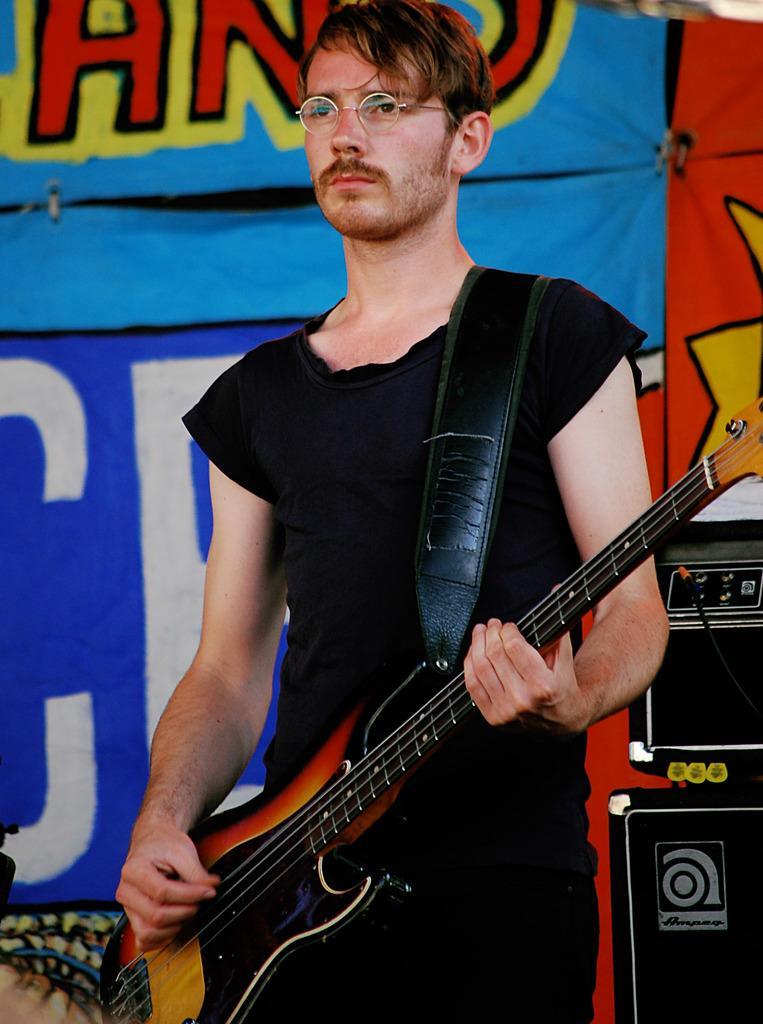Please provide a concise description of this image. In this image there is man wearing black dress is playing guitar. He is wearing glasses. Beside him there are some musical instruments. In the background there is a banner. 